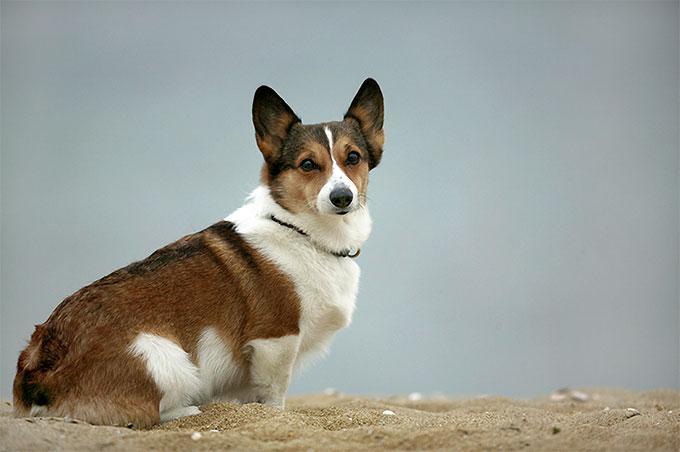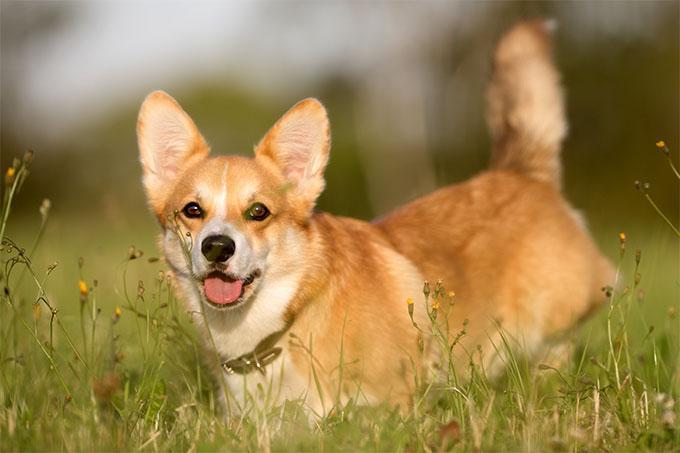The first image is the image on the left, the second image is the image on the right. Examine the images to the left and right. Is the description "At least one dog is sitting." accurate? Answer yes or no. Yes. The first image is the image on the left, the second image is the image on the right. Assess this claim about the two images: "There is a dog in the right image on a wooden surface.". Correct or not? Answer yes or no. No. 